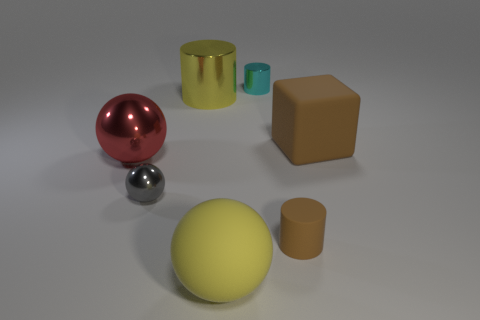The rubber ball that is the same color as the large cylinder is what size?
Your answer should be compact. Large. There is a small metal thing that is left of the big yellow metallic object; does it have the same color as the tiny cylinder in front of the big brown block?
Provide a short and direct response. No. There is a thing that is both to the left of the yellow cylinder and in front of the red shiny object; what is it made of?
Provide a succinct answer. Metal. What is the color of the big block?
Give a very brief answer. Brown. What number of other things are the same shape as the small cyan metal object?
Ensure brevity in your answer.  2. Are there the same number of big red metal spheres in front of the large yellow ball and large brown rubber objects that are in front of the big red ball?
Provide a short and direct response. Yes. What material is the big yellow cylinder?
Offer a very short reply. Metal. There is a tiny cylinder behind the gray ball; what is its material?
Your answer should be compact. Metal. Is there any other thing that has the same material as the big yellow ball?
Provide a short and direct response. Yes. Are there more big shiny objects that are on the right side of the large brown block than yellow metallic cylinders?
Your response must be concise. No. 